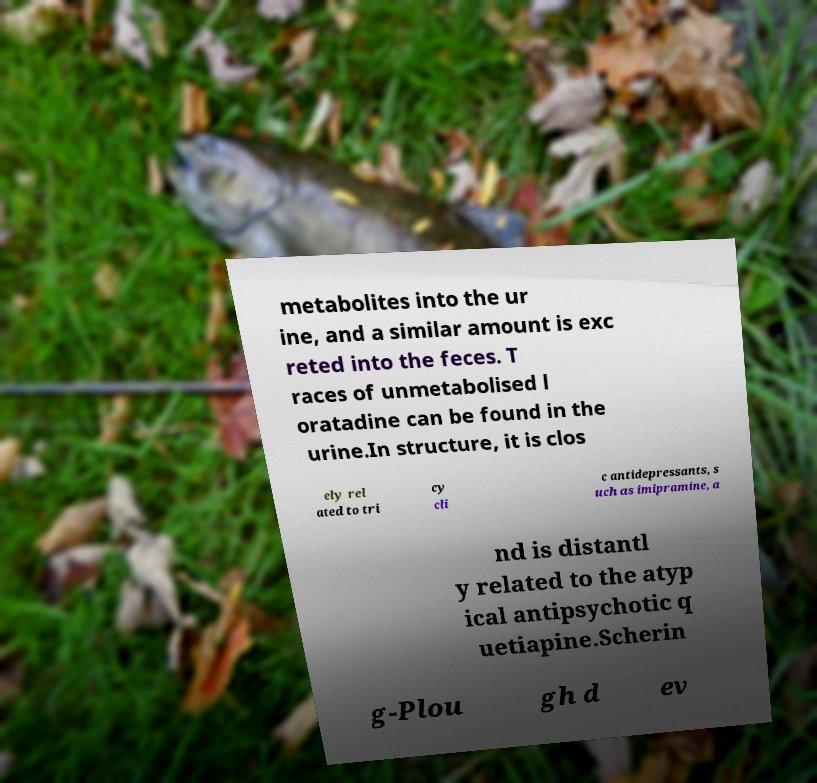Please identify and transcribe the text found in this image. metabolites into the ur ine, and a similar amount is exc reted into the feces. T races of unmetabolised l oratadine can be found in the urine.In structure, it is clos ely rel ated to tri cy cli c antidepressants, s uch as imipramine, a nd is distantl y related to the atyp ical antipsychotic q uetiapine.Scherin g-Plou gh d ev 